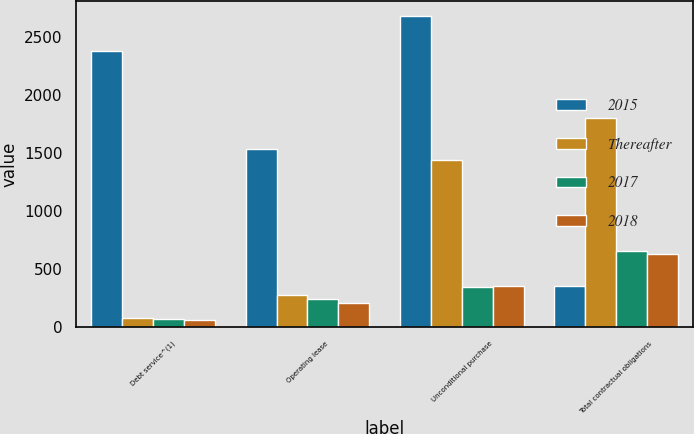Convert chart to OTSL. <chart><loc_0><loc_0><loc_500><loc_500><stacked_bar_chart><ecel><fcel>Debt service^(1)<fcel>Operating lease<fcel>Unconditional purchase<fcel>Total contractual obligations<nl><fcel>2015<fcel>2386.3<fcel>1534.7<fcel>2681.7<fcel>358.2<nl><fcel>Thereafter<fcel>79.6<fcel>280.2<fcel>1441.6<fcel>1802.3<nl><fcel>2017<fcel>65.5<fcel>241<fcel>346.3<fcel>652.8<nl><fcel>2018<fcel>61.8<fcel>210.9<fcel>358.2<fcel>630.9<nl></chart> 